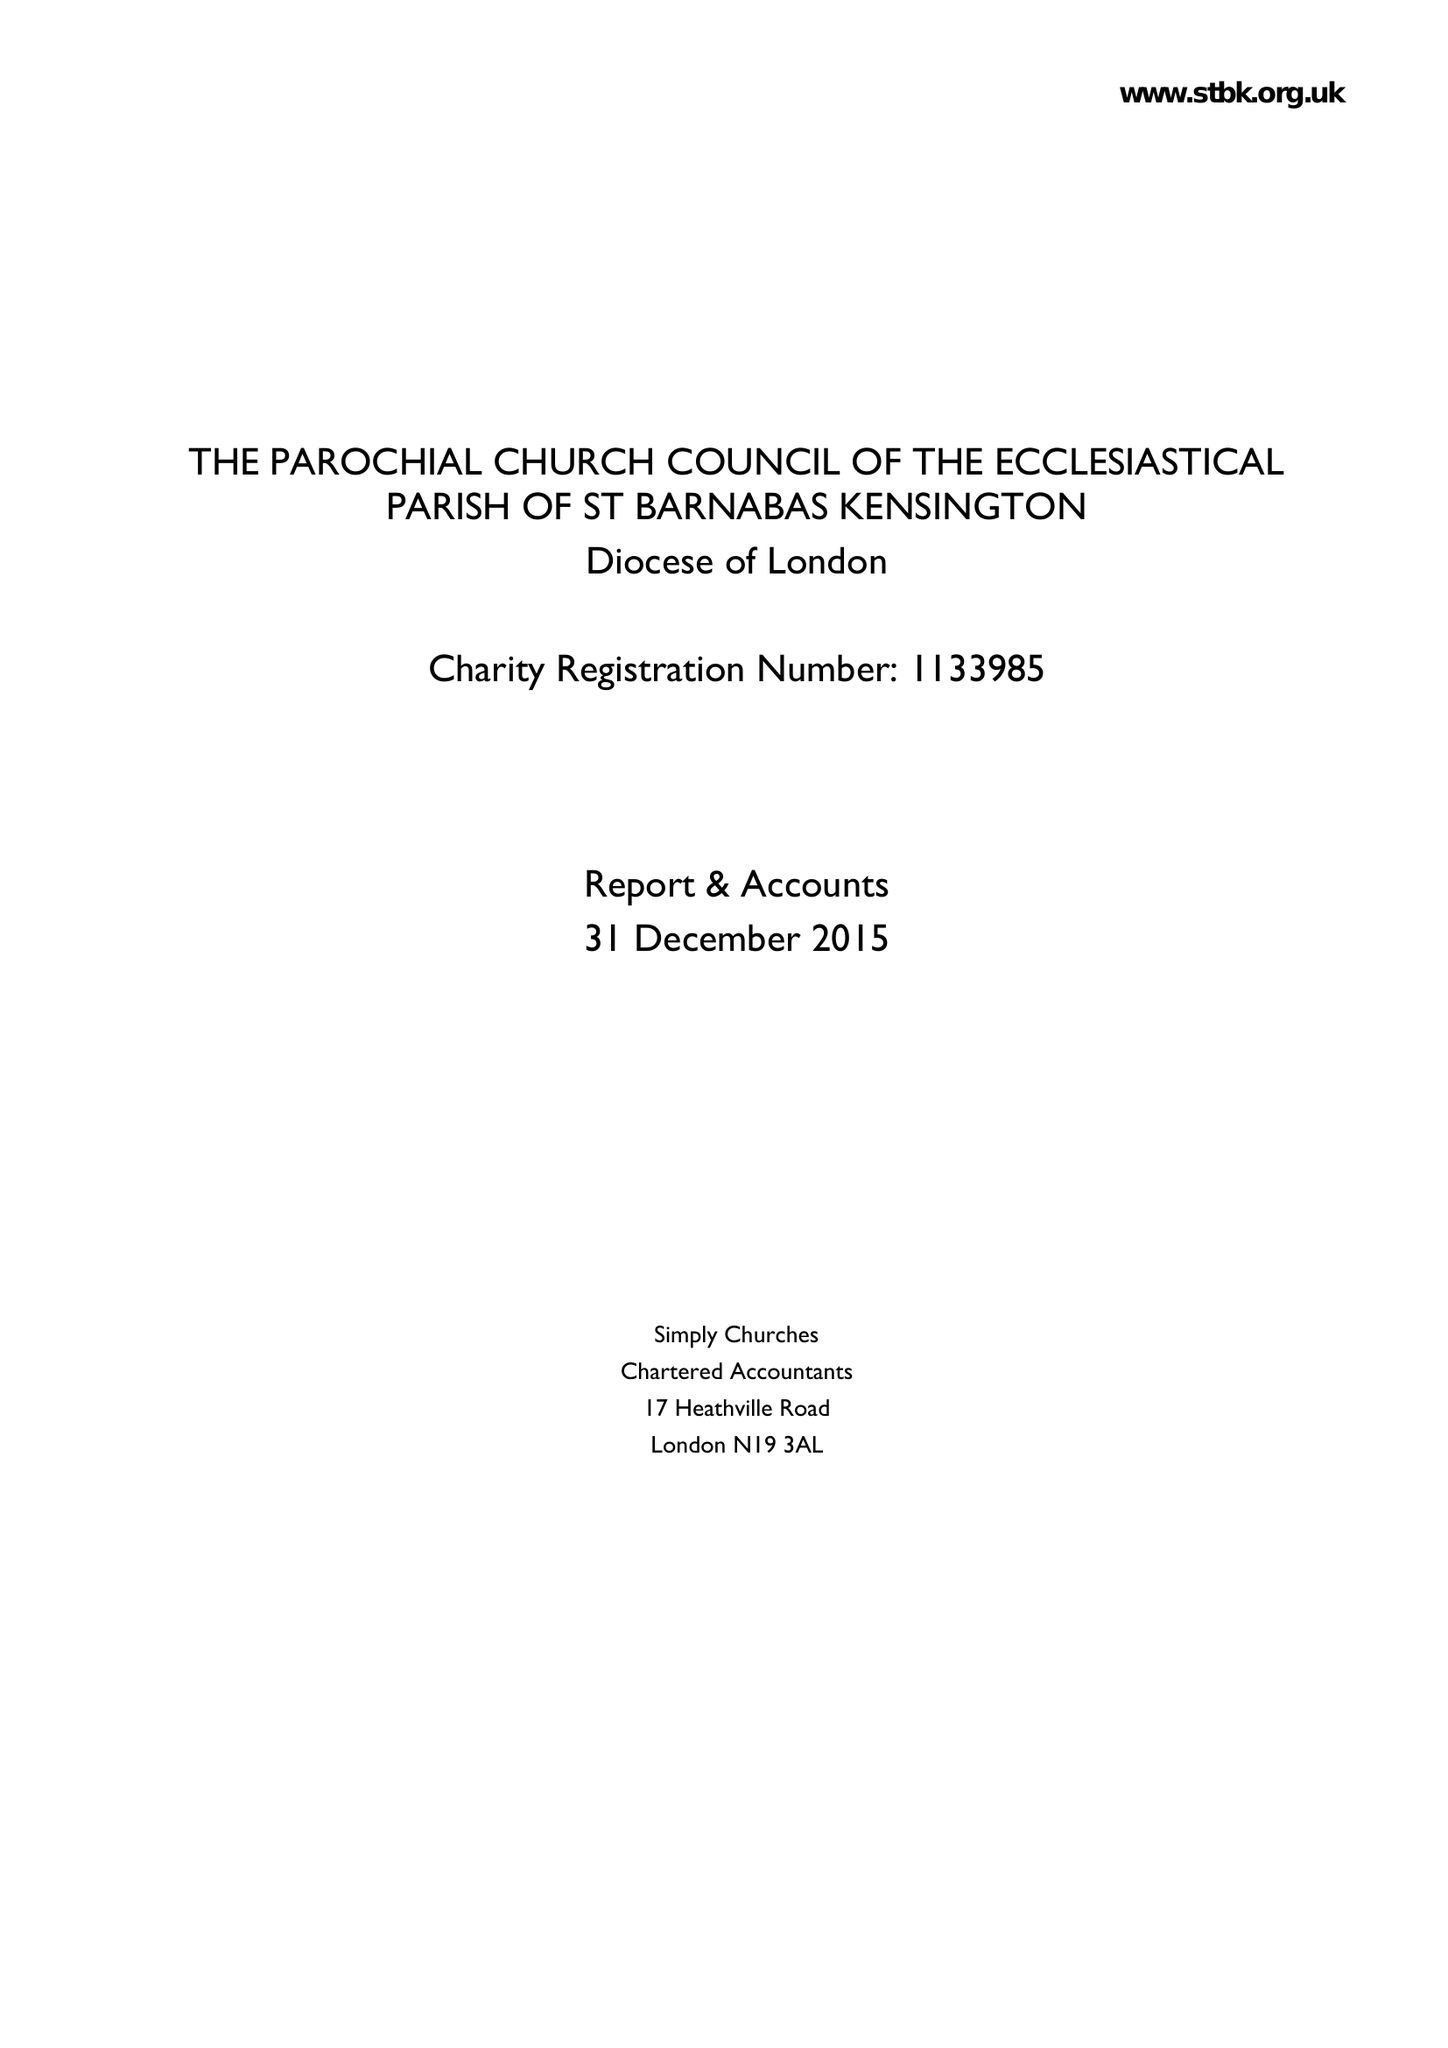What is the value for the address__postcode?
Answer the question using a single word or phrase. W14 8LH 